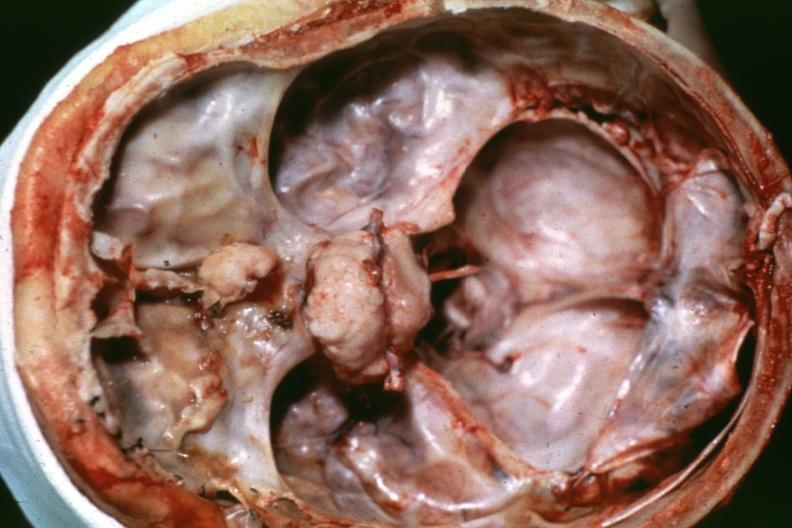does this image show anterior fossa lesion dr garcia tumors b42?
Answer the question using a single word or phrase. Yes 